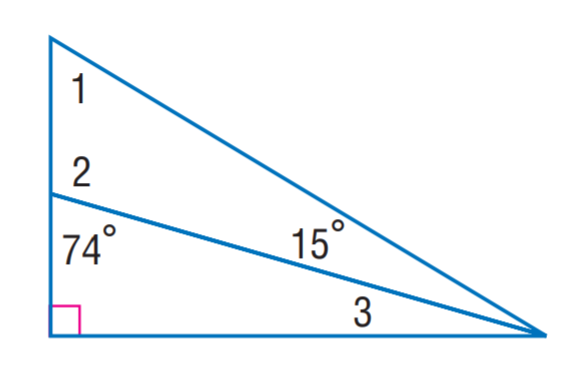Question: Find m \angle 2.
Choices:
A. 59
B. 74
C. 106
D. 110
Answer with the letter. Answer: C Question: Find m \angle 3.
Choices:
A. 15
B. 16
C. 18
D. 20
Answer with the letter. Answer: B Question: Find m \angle 1.
Choices:
A. 15
B. 43
C. 59
D. 71
Answer with the letter. Answer: C 